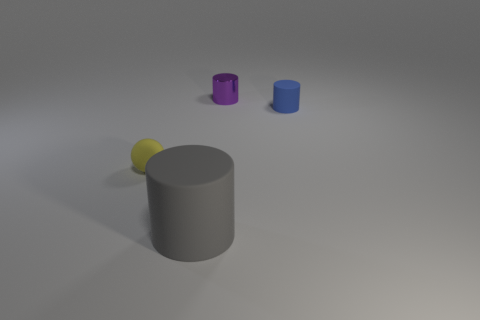The matte thing that is behind the large matte object and left of the purple metal cylinder has what shape?
Offer a terse response. Sphere. Is the color of the object that is on the left side of the large matte thing the same as the small metallic cylinder?
Your response must be concise. No. Is the shape of the small thing that is to the left of the gray cylinder the same as the small thing right of the tiny purple object?
Offer a very short reply. No. There is a cylinder that is behind the small blue object; what is its size?
Ensure brevity in your answer.  Small. There is a thing that is to the left of the gray rubber object in front of the metal object; what is its size?
Your response must be concise. Small. Are there more purple cylinders than brown rubber objects?
Provide a succinct answer. Yes. Are there more large gray matte cylinders on the left side of the matte sphere than tiny metallic cylinders that are behind the tiny rubber cylinder?
Your response must be concise. No. What size is the cylinder that is both to the left of the tiny blue cylinder and to the right of the big gray matte cylinder?
Your answer should be compact. Small. What number of red blocks have the same size as the matte sphere?
Make the answer very short. 0. There is a matte thing on the right side of the metallic cylinder; is it the same shape as the small yellow matte object?
Make the answer very short. No. 